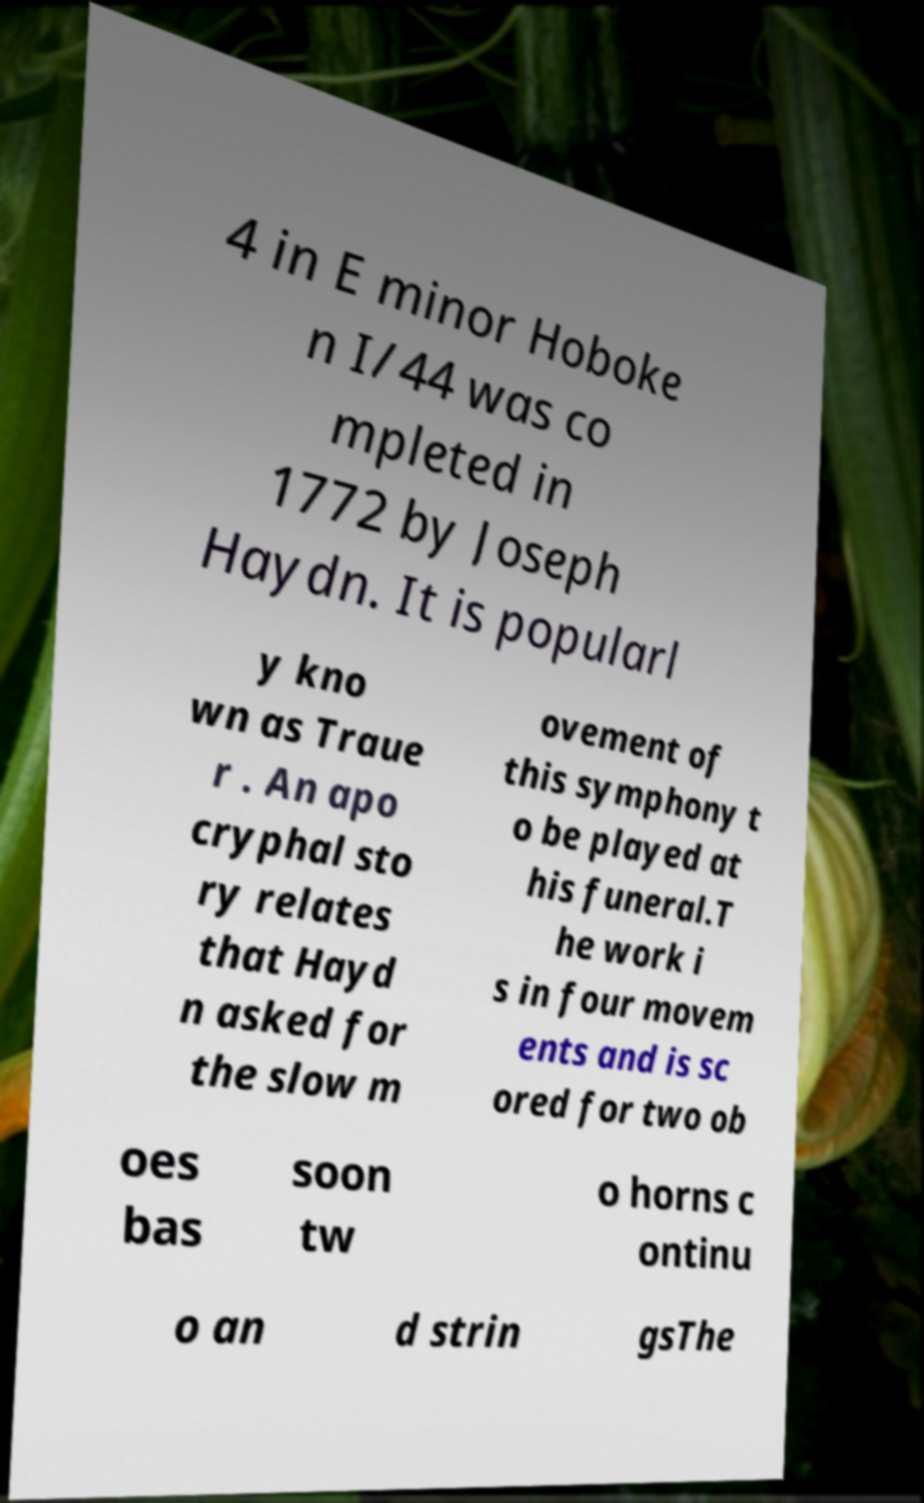Please read and relay the text visible in this image. What does it say? 4 in E minor Hoboke n I/44 was co mpleted in 1772 by Joseph Haydn. It is popularl y kno wn as Traue r . An apo cryphal sto ry relates that Hayd n asked for the slow m ovement of this symphony t o be played at his funeral.T he work i s in four movem ents and is sc ored for two ob oes bas soon tw o horns c ontinu o an d strin gsThe 